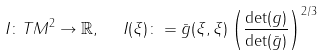Convert formula to latex. <formula><loc_0><loc_0><loc_500><loc_500>I \colon T M ^ { 2 } \to \mathbb { R } , \ \ I ( \xi ) \colon = \bar { g } ( \xi , \xi ) \left ( \frac { \det ( g ) } { \det ( \bar { g } ) } \right ) ^ { 2 / 3 }</formula> 